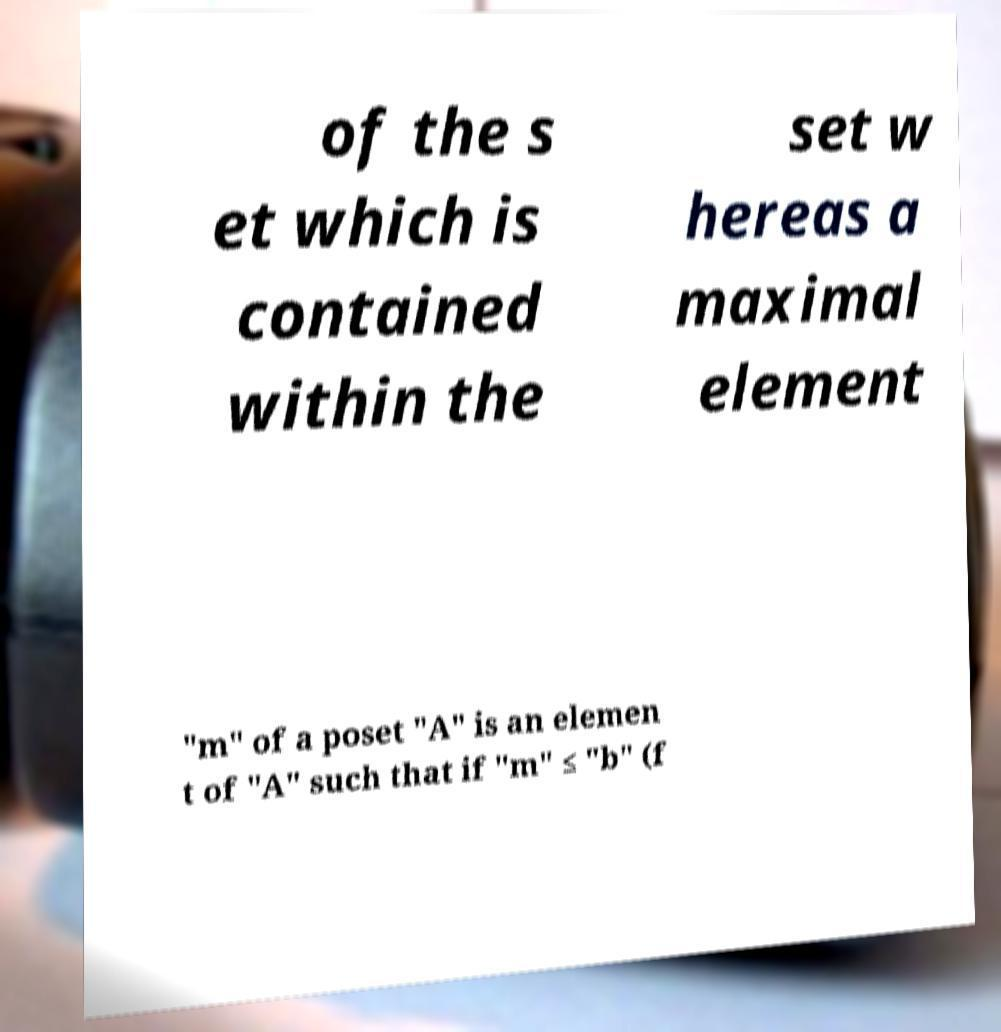What messages or text are displayed in this image? I need them in a readable, typed format. of the s et which is contained within the set w hereas a maximal element "m" of a poset "A" is an elemen t of "A" such that if "m" ≤ "b" (f 